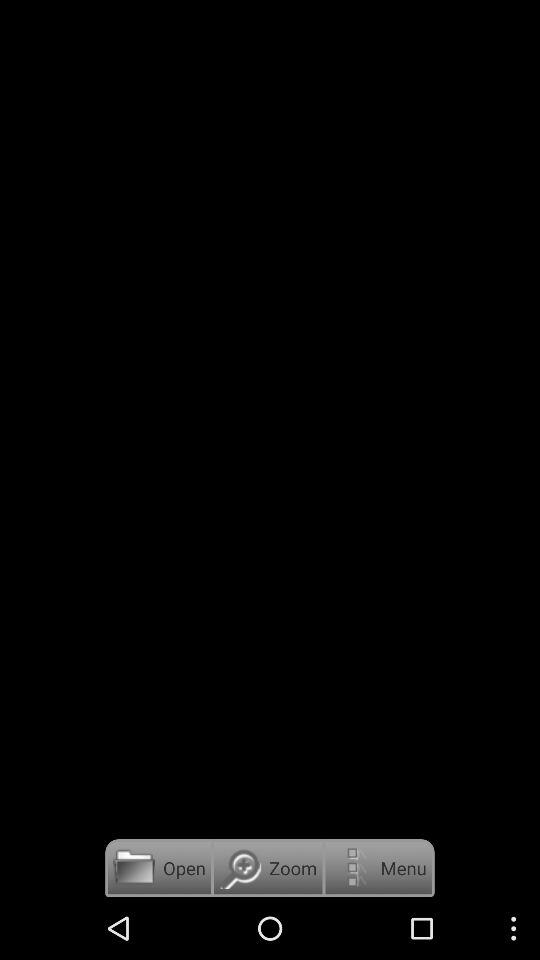What is the selected option? The selected option is "High Resolution installer". 